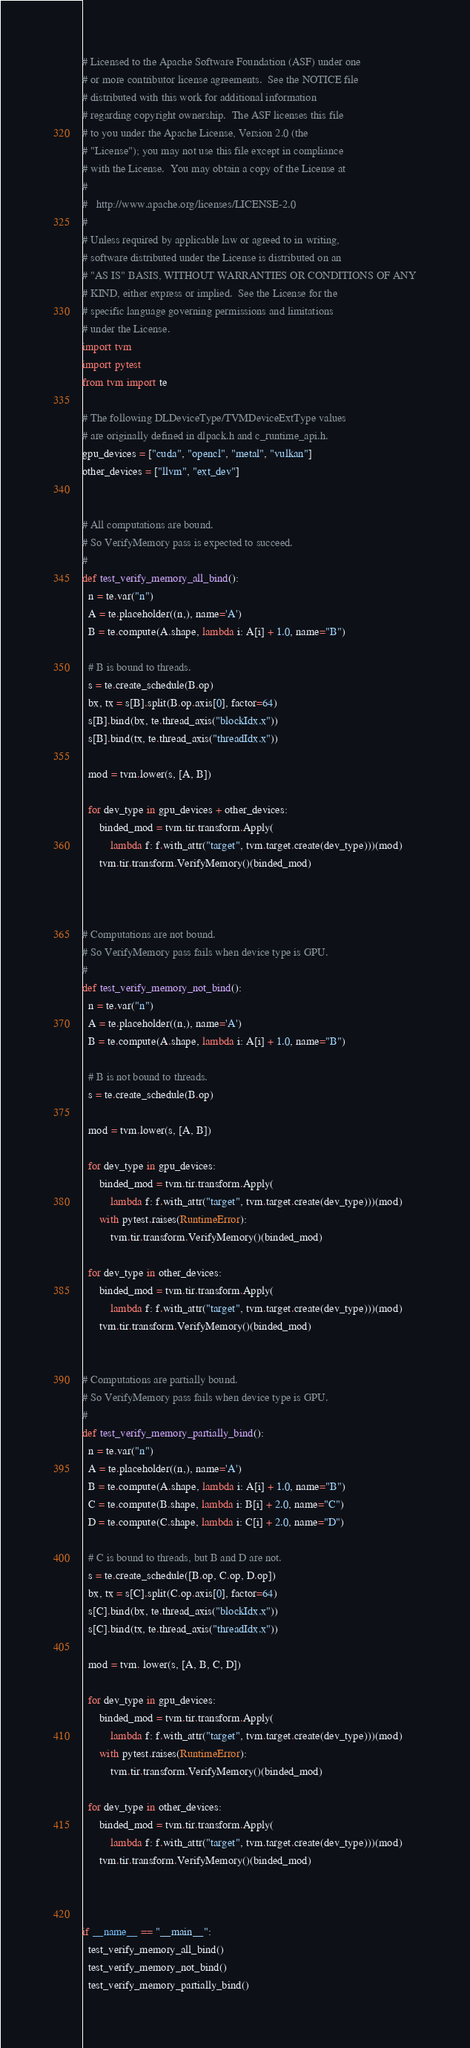Convert code to text. <code><loc_0><loc_0><loc_500><loc_500><_Python_># Licensed to the Apache Software Foundation (ASF) under one
# or more contributor license agreements.  See the NOTICE file
# distributed with this work for additional information
# regarding copyright ownership.  The ASF licenses this file
# to you under the Apache License, Version 2.0 (the
# "License"); you may not use this file except in compliance
# with the License.  You may obtain a copy of the License at
#
#   http://www.apache.org/licenses/LICENSE-2.0
#
# Unless required by applicable law or agreed to in writing,
# software distributed under the License is distributed on an
# "AS IS" BASIS, WITHOUT WARRANTIES OR CONDITIONS OF ANY
# KIND, either express or implied.  See the License for the
# specific language governing permissions and limitations
# under the License.
import tvm
import pytest
from tvm import te

# The following DLDeviceType/TVMDeviceExtType values
# are originally defined in dlpack.h and c_runtime_api.h.
gpu_devices = ["cuda", "opencl", "metal", "vulkan"]
other_devices = ["llvm", "ext_dev"]


# All computations are bound.
# So VerifyMemory pass is expected to succeed.
#
def test_verify_memory_all_bind():
  n = te.var("n")
  A = te.placeholder((n,), name='A')
  B = te.compute(A.shape, lambda i: A[i] + 1.0, name="B")

  # B is bound to threads.
  s = te.create_schedule(B.op)
  bx, tx = s[B].split(B.op.axis[0], factor=64)
  s[B].bind(bx, te.thread_axis("blockIdx.x"))
  s[B].bind(tx, te.thread_axis("threadIdx.x"))

  mod = tvm.lower(s, [A, B])

  for dev_type in gpu_devices + other_devices:
      binded_mod = tvm.tir.transform.Apply(
          lambda f: f.with_attr("target", tvm.target.create(dev_type)))(mod)
      tvm.tir.transform.VerifyMemory()(binded_mod)



# Computations are not bound.
# So VerifyMemory pass fails when device type is GPU.
#
def test_verify_memory_not_bind():
  n = te.var("n")
  A = te.placeholder((n,), name='A')
  B = te.compute(A.shape, lambda i: A[i] + 1.0, name="B")

  # B is not bound to threads.
  s = te.create_schedule(B.op)

  mod = tvm.lower(s, [A, B])

  for dev_type in gpu_devices:
      binded_mod = tvm.tir.transform.Apply(
          lambda f: f.with_attr("target", tvm.target.create(dev_type)))(mod)
      with pytest.raises(RuntimeError):
          tvm.tir.transform.VerifyMemory()(binded_mod)

  for dev_type in other_devices:
      binded_mod = tvm.tir.transform.Apply(
          lambda f: f.with_attr("target", tvm.target.create(dev_type)))(mod)
      tvm.tir.transform.VerifyMemory()(binded_mod)


# Computations are partially bound.
# So VerifyMemory pass fails when device type is GPU.
#
def test_verify_memory_partially_bind():
  n = te.var("n")
  A = te.placeholder((n,), name='A')
  B = te.compute(A.shape, lambda i: A[i] + 1.0, name="B")
  C = te.compute(B.shape, lambda i: B[i] + 2.0, name="C")
  D = te.compute(C.shape, lambda i: C[i] + 2.0, name="D")

  # C is bound to threads, but B and D are not.
  s = te.create_schedule([B.op, C.op, D.op])
  bx, tx = s[C].split(C.op.axis[0], factor=64)
  s[C].bind(bx, te.thread_axis("blockIdx.x"))
  s[C].bind(tx, te.thread_axis("threadIdx.x"))

  mod = tvm. lower(s, [A, B, C, D])

  for dev_type in gpu_devices:
      binded_mod = tvm.tir.transform.Apply(
          lambda f: f.with_attr("target", tvm.target.create(dev_type)))(mod)
      with pytest.raises(RuntimeError):
          tvm.tir.transform.VerifyMemory()(binded_mod)

  for dev_type in other_devices:
      binded_mod = tvm.tir.transform.Apply(
          lambda f: f.with_attr("target", tvm.target.create(dev_type)))(mod)
      tvm.tir.transform.VerifyMemory()(binded_mod)



if __name__ == "__main__":
  test_verify_memory_all_bind()
  test_verify_memory_not_bind()
  test_verify_memory_partially_bind()
</code> 